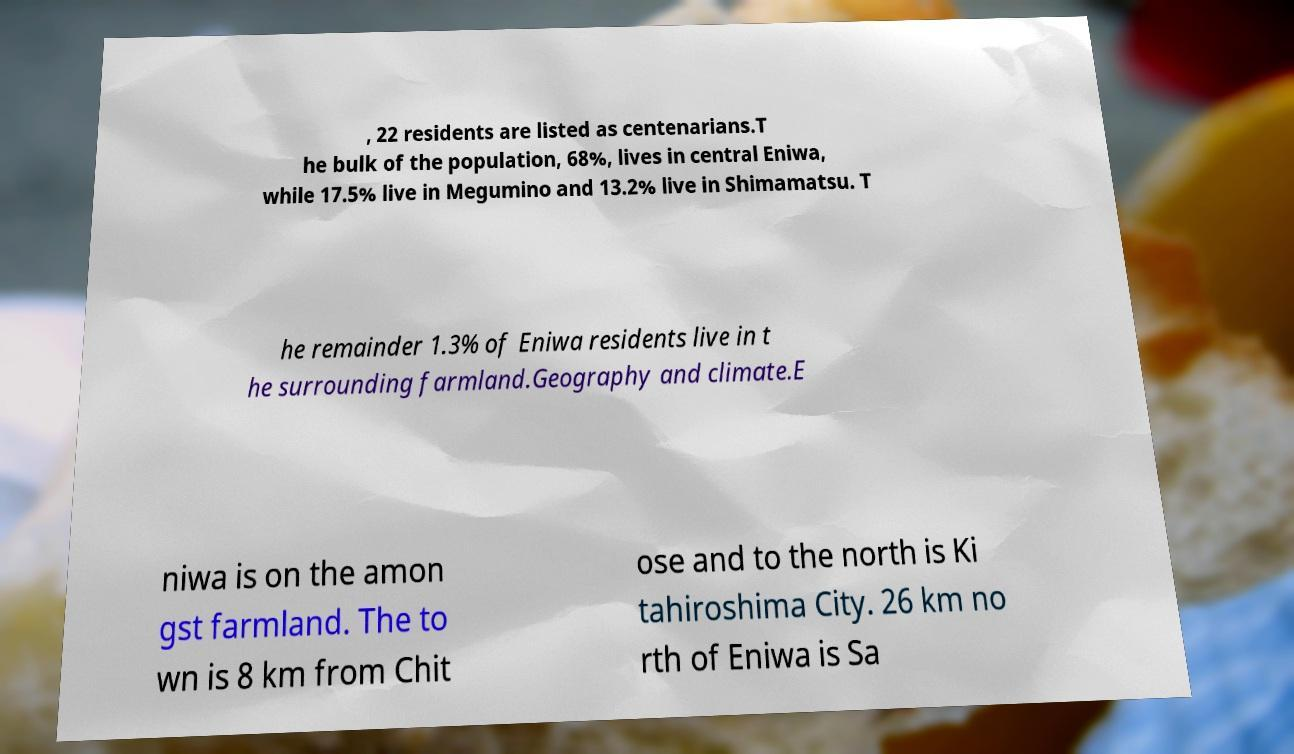Could you extract and type out the text from this image? , 22 residents are listed as centenarians.T he bulk of the population, 68%, lives in central Eniwa, while 17.5% live in Megumino and 13.2% live in Shimamatsu. T he remainder 1.3% of Eniwa residents live in t he surrounding farmland.Geography and climate.E niwa is on the amon gst farmland. The to wn is 8 km from Chit ose and to the north is Ki tahiroshima City. 26 km no rth of Eniwa is Sa 